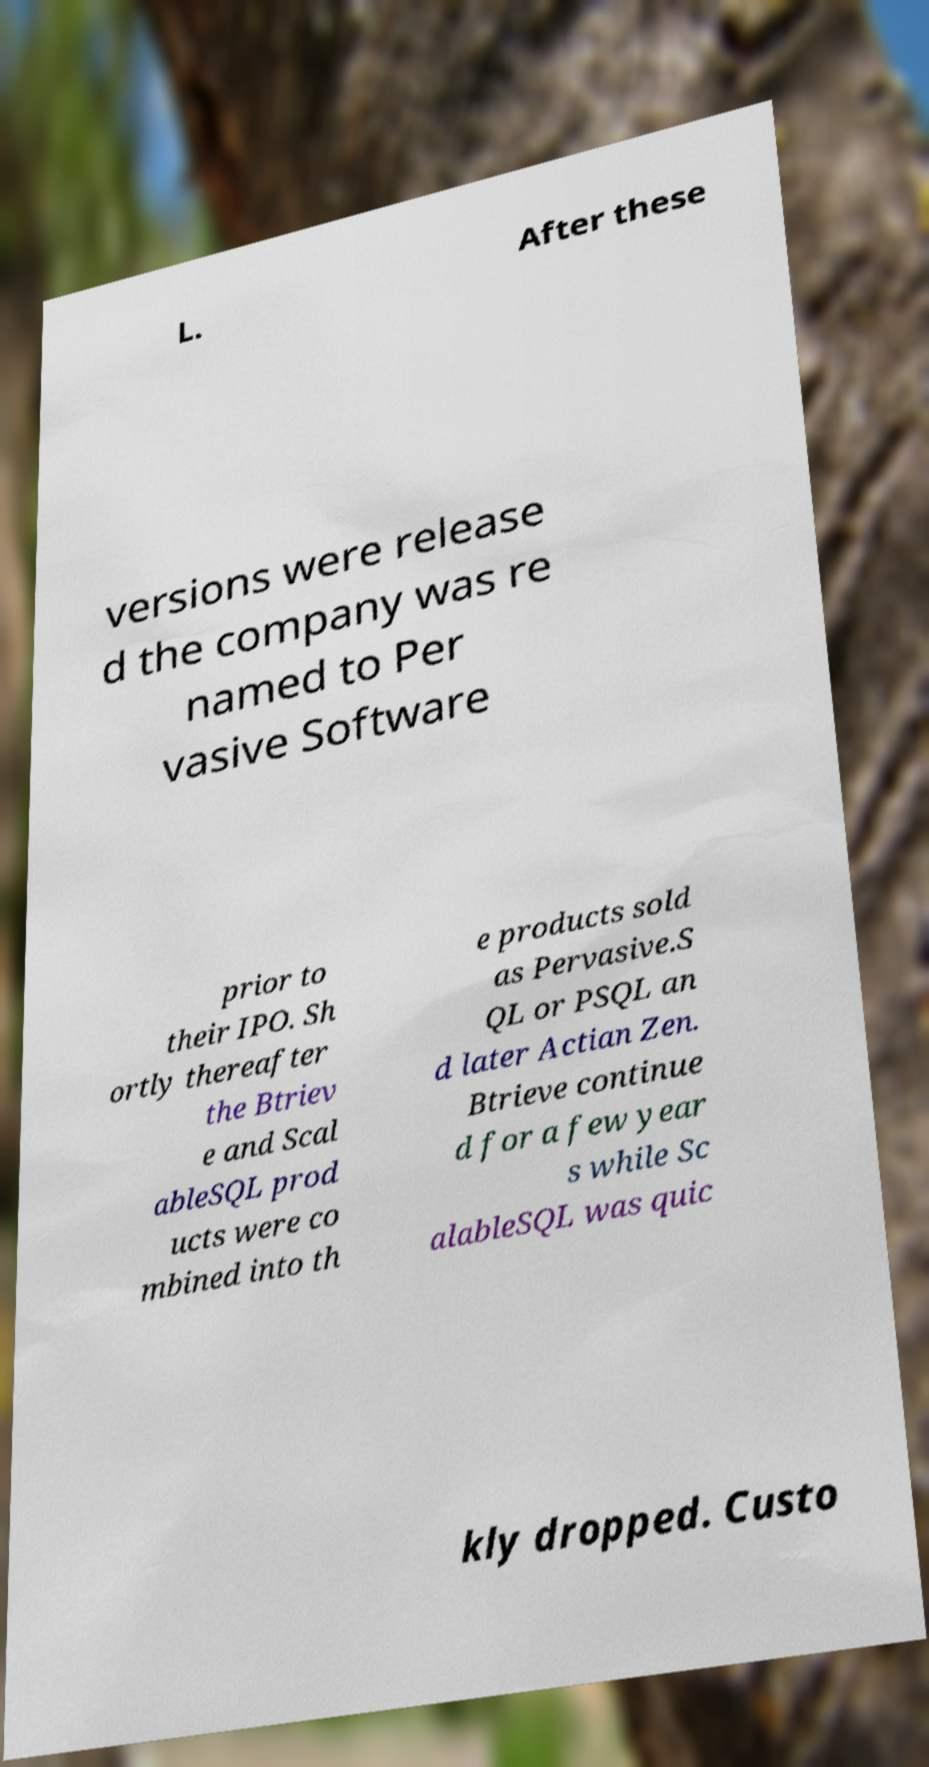For documentation purposes, I need the text within this image transcribed. Could you provide that? L. After these versions were release d the company was re named to Per vasive Software prior to their IPO. Sh ortly thereafter the Btriev e and Scal ableSQL prod ucts were co mbined into th e products sold as Pervasive.S QL or PSQL an d later Actian Zen. Btrieve continue d for a few year s while Sc alableSQL was quic kly dropped. Custo 